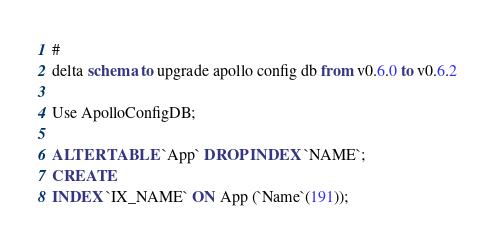Convert code to text. <code><loc_0><loc_0><loc_500><loc_500><_SQL_>#
delta schema to upgrade apollo config db from v0.6.0 to v0.6.2

Use ApolloConfigDB;

ALTER TABLE `App` DROP INDEX `NAME`;
CREATE
INDEX `IX_NAME` ON App (`Name`(191));
</code> 